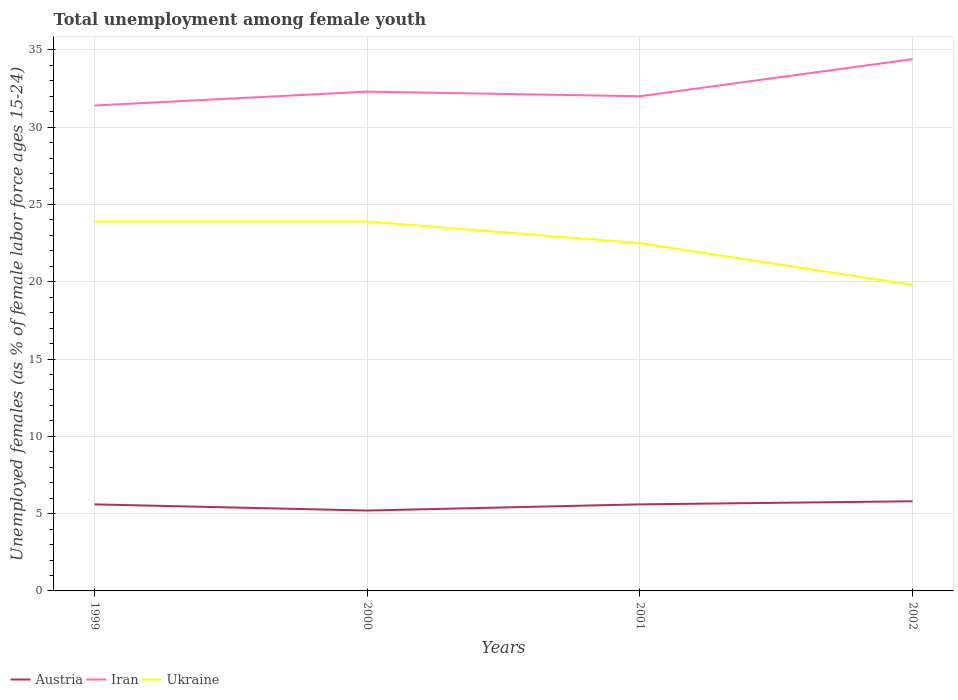Is the number of lines equal to the number of legend labels?
Offer a very short reply. Yes. Across all years, what is the maximum percentage of unemployed females in in Iran?
Offer a terse response. 31.4. What is the total percentage of unemployed females in in Iran in the graph?
Your answer should be compact. -3. What is the difference between the highest and the second highest percentage of unemployed females in in Austria?
Give a very brief answer. 0.6. Is the percentage of unemployed females in in Ukraine strictly greater than the percentage of unemployed females in in Iran over the years?
Provide a short and direct response. Yes. How many years are there in the graph?
Provide a short and direct response. 4. What is the difference between two consecutive major ticks on the Y-axis?
Offer a very short reply. 5. Are the values on the major ticks of Y-axis written in scientific E-notation?
Provide a succinct answer. No. Does the graph contain any zero values?
Your answer should be very brief. No. Where does the legend appear in the graph?
Keep it short and to the point. Bottom left. How many legend labels are there?
Your answer should be compact. 3. What is the title of the graph?
Make the answer very short. Total unemployment among female youth. What is the label or title of the Y-axis?
Offer a terse response. Unemployed females (as % of female labor force ages 15-24). What is the Unemployed females (as % of female labor force ages 15-24) in Austria in 1999?
Give a very brief answer. 5.6. What is the Unemployed females (as % of female labor force ages 15-24) of Iran in 1999?
Make the answer very short. 31.4. What is the Unemployed females (as % of female labor force ages 15-24) of Ukraine in 1999?
Your response must be concise. 23.9. What is the Unemployed females (as % of female labor force ages 15-24) in Austria in 2000?
Give a very brief answer. 5.2. What is the Unemployed females (as % of female labor force ages 15-24) in Iran in 2000?
Provide a short and direct response. 32.3. What is the Unemployed females (as % of female labor force ages 15-24) of Ukraine in 2000?
Provide a succinct answer. 23.9. What is the Unemployed females (as % of female labor force ages 15-24) of Austria in 2001?
Give a very brief answer. 5.6. What is the Unemployed females (as % of female labor force ages 15-24) of Iran in 2001?
Offer a terse response. 32. What is the Unemployed females (as % of female labor force ages 15-24) of Austria in 2002?
Give a very brief answer. 5.8. What is the Unemployed females (as % of female labor force ages 15-24) in Iran in 2002?
Give a very brief answer. 34.4. What is the Unemployed females (as % of female labor force ages 15-24) in Ukraine in 2002?
Your response must be concise. 19.8. Across all years, what is the maximum Unemployed females (as % of female labor force ages 15-24) in Austria?
Your answer should be compact. 5.8. Across all years, what is the maximum Unemployed females (as % of female labor force ages 15-24) of Iran?
Provide a short and direct response. 34.4. Across all years, what is the maximum Unemployed females (as % of female labor force ages 15-24) in Ukraine?
Keep it short and to the point. 23.9. Across all years, what is the minimum Unemployed females (as % of female labor force ages 15-24) in Austria?
Give a very brief answer. 5.2. Across all years, what is the minimum Unemployed females (as % of female labor force ages 15-24) in Iran?
Give a very brief answer. 31.4. Across all years, what is the minimum Unemployed females (as % of female labor force ages 15-24) in Ukraine?
Make the answer very short. 19.8. What is the total Unemployed females (as % of female labor force ages 15-24) of Austria in the graph?
Offer a terse response. 22.2. What is the total Unemployed females (as % of female labor force ages 15-24) in Iran in the graph?
Provide a succinct answer. 130.1. What is the total Unemployed females (as % of female labor force ages 15-24) of Ukraine in the graph?
Provide a succinct answer. 90.1. What is the difference between the Unemployed females (as % of female labor force ages 15-24) of Iran in 1999 and that in 2000?
Your response must be concise. -0.9. What is the difference between the Unemployed females (as % of female labor force ages 15-24) in Iran in 1999 and that in 2001?
Ensure brevity in your answer.  -0.6. What is the difference between the Unemployed females (as % of female labor force ages 15-24) in Ukraine in 1999 and that in 2001?
Give a very brief answer. 1.4. What is the difference between the Unemployed females (as % of female labor force ages 15-24) of Iran in 1999 and that in 2002?
Ensure brevity in your answer.  -3. What is the difference between the Unemployed females (as % of female labor force ages 15-24) in Austria in 2000 and that in 2001?
Your answer should be very brief. -0.4. What is the difference between the Unemployed females (as % of female labor force ages 15-24) in Ukraine in 2000 and that in 2001?
Give a very brief answer. 1.4. What is the difference between the Unemployed females (as % of female labor force ages 15-24) in Iran in 2000 and that in 2002?
Your answer should be compact. -2.1. What is the difference between the Unemployed females (as % of female labor force ages 15-24) of Austria in 2001 and that in 2002?
Offer a terse response. -0.2. What is the difference between the Unemployed females (as % of female labor force ages 15-24) of Iran in 2001 and that in 2002?
Your response must be concise. -2.4. What is the difference between the Unemployed females (as % of female labor force ages 15-24) in Ukraine in 2001 and that in 2002?
Give a very brief answer. 2.7. What is the difference between the Unemployed females (as % of female labor force ages 15-24) of Austria in 1999 and the Unemployed females (as % of female labor force ages 15-24) of Iran in 2000?
Your response must be concise. -26.7. What is the difference between the Unemployed females (as % of female labor force ages 15-24) of Austria in 1999 and the Unemployed females (as % of female labor force ages 15-24) of Ukraine in 2000?
Offer a very short reply. -18.3. What is the difference between the Unemployed females (as % of female labor force ages 15-24) in Iran in 1999 and the Unemployed females (as % of female labor force ages 15-24) in Ukraine in 2000?
Ensure brevity in your answer.  7.5. What is the difference between the Unemployed females (as % of female labor force ages 15-24) in Austria in 1999 and the Unemployed females (as % of female labor force ages 15-24) in Iran in 2001?
Your answer should be very brief. -26.4. What is the difference between the Unemployed females (as % of female labor force ages 15-24) in Austria in 1999 and the Unemployed females (as % of female labor force ages 15-24) in Ukraine in 2001?
Your answer should be very brief. -16.9. What is the difference between the Unemployed females (as % of female labor force ages 15-24) of Iran in 1999 and the Unemployed females (as % of female labor force ages 15-24) of Ukraine in 2001?
Make the answer very short. 8.9. What is the difference between the Unemployed females (as % of female labor force ages 15-24) of Austria in 1999 and the Unemployed females (as % of female labor force ages 15-24) of Iran in 2002?
Your answer should be very brief. -28.8. What is the difference between the Unemployed females (as % of female labor force ages 15-24) of Austria in 2000 and the Unemployed females (as % of female labor force ages 15-24) of Iran in 2001?
Provide a short and direct response. -26.8. What is the difference between the Unemployed females (as % of female labor force ages 15-24) in Austria in 2000 and the Unemployed females (as % of female labor force ages 15-24) in Ukraine in 2001?
Give a very brief answer. -17.3. What is the difference between the Unemployed females (as % of female labor force ages 15-24) in Austria in 2000 and the Unemployed females (as % of female labor force ages 15-24) in Iran in 2002?
Give a very brief answer. -29.2. What is the difference between the Unemployed females (as % of female labor force ages 15-24) of Austria in 2000 and the Unemployed females (as % of female labor force ages 15-24) of Ukraine in 2002?
Keep it short and to the point. -14.6. What is the difference between the Unemployed females (as % of female labor force ages 15-24) in Iran in 2000 and the Unemployed females (as % of female labor force ages 15-24) in Ukraine in 2002?
Your answer should be compact. 12.5. What is the difference between the Unemployed females (as % of female labor force ages 15-24) of Austria in 2001 and the Unemployed females (as % of female labor force ages 15-24) of Iran in 2002?
Your answer should be very brief. -28.8. What is the difference between the Unemployed females (as % of female labor force ages 15-24) of Austria in 2001 and the Unemployed females (as % of female labor force ages 15-24) of Ukraine in 2002?
Give a very brief answer. -14.2. What is the average Unemployed females (as % of female labor force ages 15-24) of Austria per year?
Provide a succinct answer. 5.55. What is the average Unemployed females (as % of female labor force ages 15-24) of Iran per year?
Make the answer very short. 32.52. What is the average Unemployed females (as % of female labor force ages 15-24) of Ukraine per year?
Keep it short and to the point. 22.52. In the year 1999, what is the difference between the Unemployed females (as % of female labor force ages 15-24) in Austria and Unemployed females (as % of female labor force ages 15-24) in Iran?
Give a very brief answer. -25.8. In the year 1999, what is the difference between the Unemployed females (as % of female labor force ages 15-24) in Austria and Unemployed females (as % of female labor force ages 15-24) in Ukraine?
Provide a succinct answer. -18.3. In the year 2000, what is the difference between the Unemployed females (as % of female labor force ages 15-24) in Austria and Unemployed females (as % of female labor force ages 15-24) in Iran?
Give a very brief answer. -27.1. In the year 2000, what is the difference between the Unemployed females (as % of female labor force ages 15-24) of Austria and Unemployed females (as % of female labor force ages 15-24) of Ukraine?
Offer a very short reply. -18.7. In the year 2001, what is the difference between the Unemployed females (as % of female labor force ages 15-24) in Austria and Unemployed females (as % of female labor force ages 15-24) in Iran?
Give a very brief answer. -26.4. In the year 2001, what is the difference between the Unemployed females (as % of female labor force ages 15-24) in Austria and Unemployed females (as % of female labor force ages 15-24) in Ukraine?
Provide a short and direct response. -16.9. In the year 2001, what is the difference between the Unemployed females (as % of female labor force ages 15-24) in Iran and Unemployed females (as % of female labor force ages 15-24) in Ukraine?
Your answer should be compact. 9.5. In the year 2002, what is the difference between the Unemployed females (as % of female labor force ages 15-24) of Austria and Unemployed females (as % of female labor force ages 15-24) of Iran?
Provide a short and direct response. -28.6. In the year 2002, what is the difference between the Unemployed females (as % of female labor force ages 15-24) of Iran and Unemployed females (as % of female labor force ages 15-24) of Ukraine?
Give a very brief answer. 14.6. What is the ratio of the Unemployed females (as % of female labor force ages 15-24) of Austria in 1999 to that in 2000?
Ensure brevity in your answer.  1.08. What is the ratio of the Unemployed females (as % of female labor force ages 15-24) of Iran in 1999 to that in 2000?
Provide a succinct answer. 0.97. What is the ratio of the Unemployed females (as % of female labor force ages 15-24) of Ukraine in 1999 to that in 2000?
Make the answer very short. 1. What is the ratio of the Unemployed females (as % of female labor force ages 15-24) of Austria in 1999 to that in 2001?
Ensure brevity in your answer.  1. What is the ratio of the Unemployed females (as % of female labor force ages 15-24) in Iran in 1999 to that in 2001?
Provide a succinct answer. 0.98. What is the ratio of the Unemployed females (as % of female labor force ages 15-24) in Ukraine in 1999 to that in 2001?
Ensure brevity in your answer.  1.06. What is the ratio of the Unemployed females (as % of female labor force ages 15-24) in Austria in 1999 to that in 2002?
Offer a very short reply. 0.97. What is the ratio of the Unemployed females (as % of female labor force ages 15-24) of Iran in 1999 to that in 2002?
Offer a terse response. 0.91. What is the ratio of the Unemployed females (as % of female labor force ages 15-24) in Ukraine in 1999 to that in 2002?
Keep it short and to the point. 1.21. What is the ratio of the Unemployed females (as % of female labor force ages 15-24) in Austria in 2000 to that in 2001?
Make the answer very short. 0.93. What is the ratio of the Unemployed females (as % of female labor force ages 15-24) in Iran in 2000 to that in 2001?
Your answer should be compact. 1.01. What is the ratio of the Unemployed females (as % of female labor force ages 15-24) in Ukraine in 2000 to that in 2001?
Make the answer very short. 1.06. What is the ratio of the Unemployed females (as % of female labor force ages 15-24) in Austria in 2000 to that in 2002?
Offer a terse response. 0.9. What is the ratio of the Unemployed females (as % of female labor force ages 15-24) of Iran in 2000 to that in 2002?
Keep it short and to the point. 0.94. What is the ratio of the Unemployed females (as % of female labor force ages 15-24) of Ukraine in 2000 to that in 2002?
Keep it short and to the point. 1.21. What is the ratio of the Unemployed females (as % of female labor force ages 15-24) of Austria in 2001 to that in 2002?
Offer a terse response. 0.97. What is the ratio of the Unemployed females (as % of female labor force ages 15-24) in Iran in 2001 to that in 2002?
Offer a very short reply. 0.93. What is the ratio of the Unemployed females (as % of female labor force ages 15-24) in Ukraine in 2001 to that in 2002?
Ensure brevity in your answer.  1.14. What is the difference between the highest and the second highest Unemployed females (as % of female labor force ages 15-24) in Iran?
Your answer should be very brief. 2.1. What is the difference between the highest and the second highest Unemployed females (as % of female labor force ages 15-24) of Ukraine?
Your answer should be compact. 0. What is the difference between the highest and the lowest Unemployed females (as % of female labor force ages 15-24) in Iran?
Make the answer very short. 3. 